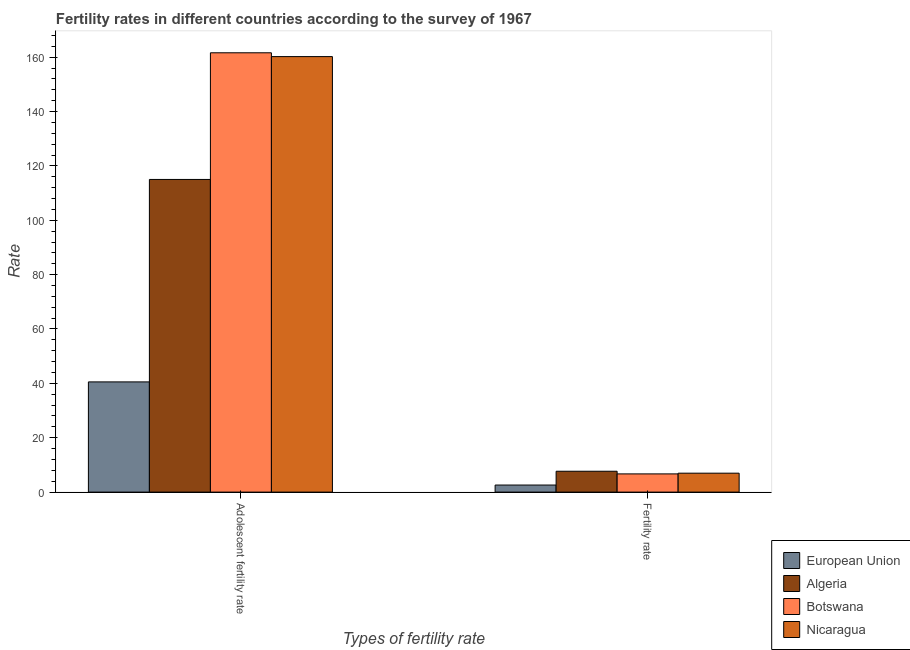How many groups of bars are there?
Your response must be concise. 2. How many bars are there on the 1st tick from the left?
Provide a short and direct response. 4. How many bars are there on the 1st tick from the right?
Keep it short and to the point. 4. What is the label of the 1st group of bars from the left?
Provide a succinct answer. Adolescent fertility rate. What is the adolescent fertility rate in Nicaragua?
Provide a succinct answer. 160.2. Across all countries, what is the maximum fertility rate?
Keep it short and to the point. 7.67. Across all countries, what is the minimum adolescent fertility rate?
Provide a short and direct response. 40.54. In which country was the adolescent fertility rate maximum?
Give a very brief answer. Botswana. What is the total adolescent fertility rate in the graph?
Your answer should be compact. 477.36. What is the difference between the adolescent fertility rate in Nicaragua and that in Botswana?
Provide a short and direct response. -1.4. What is the difference between the adolescent fertility rate in Algeria and the fertility rate in Nicaragua?
Give a very brief answer. 108.05. What is the average adolescent fertility rate per country?
Provide a short and direct response. 119.34. What is the difference between the fertility rate and adolescent fertility rate in Algeria?
Ensure brevity in your answer.  -107.34. What is the ratio of the adolescent fertility rate in Botswana to that in Algeria?
Keep it short and to the point. 1.41. What does the 1st bar from the left in Fertility rate represents?
Make the answer very short. European Union. What does the 4th bar from the right in Adolescent fertility rate represents?
Keep it short and to the point. European Union. How many countries are there in the graph?
Provide a short and direct response. 4. Are the values on the major ticks of Y-axis written in scientific E-notation?
Give a very brief answer. No. Does the graph contain any zero values?
Ensure brevity in your answer.  No. Does the graph contain grids?
Your answer should be compact. No. What is the title of the graph?
Ensure brevity in your answer.  Fertility rates in different countries according to the survey of 1967. What is the label or title of the X-axis?
Provide a succinct answer. Types of fertility rate. What is the label or title of the Y-axis?
Your answer should be compact. Rate. What is the Rate in European Union in Adolescent fertility rate?
Your response must be concise. 40.54. What is the Rate of Algeria in Adolescent fertility rate?
Make the answer very short. 115.01. What is the Rate in Botswana in Adolescent fertility rate?
Provide a short and direct response. 161.6. What is the Rate of Nicaragua in Adolescent fertility rate?
Your answer should be very brief. 160.2. What is the Rate of European Union in Fertility rate?
Provide a succinct answer. 2.6. What is the Rate of Algeria in Fertility rate?
Offer a terse response. 7.67. What is the Rate in Botswana in Fertility rate?
Offer a very short reply. 6.7. What is the Rate of Nicaragua in Fertility rate?
Your answer should be compact. 6.96. Across all Types of fertility rate, what is the maximum Rate of European Union?
Give a very brief answer. 40.54. Across all Types of fertility rate, what is the maximum Rate of Algeria?
Give a very brief answer. 115.01. Across all Types of fertility rate, what is the maximum Rate of Botswana?
Offer a terse response. 161.6. Across all Types of fertility rate, what is the maximum Rate of Nicaragua?
Your response must be concise. 160.2. Across all Types of fertility rate, what is the minimum Rate of European Union?
Keep it short and to the point. 2.6. Across all Types of fertility rate, what is the minimum Rate in Algeria?
Your answer should be very brief. 7.67. Across all Types of fertility rate, what is the minimum Rate of Botswana?
Keep it short and to the point. 6.7. Across all Types of fertility rate, what is the minimum Rate of Nicaragua?
Your answer should be very brief. 6.96. What is the total Rate in European Union in the graph?
Offer a terse response. 43.14. What is the total Rate in Algeria in the graph?
Make the answer very short. 122.68. What is the total Rate in Botswana in the graph?
Keep it short and to the point. 168.3. What is the total Rate of Nicaragua in the graph?
Make the answer very short. 167.16. What is the difference between the Rate of European Union in Adolescent fertility rate and that in Fertility rate?
Make the answer very short. 37.94. What is the difference between the Rate in Algeria in Adolescent fertility rate and that in Fertility rate?
Provide a short and direct response. 107.34. What is the difference between the Rate of Botswana in Adolescent fertility rate and that in Fertility rate?
Provide a short and direct response. 154.91. What is the difference between the Rate of Nicaragua in Adolescent fertility rate and that in Fertility rate?
Make the answer very short. 153.24. What is the difference between the Rate in European Union in Adolescent fertility rate and the Rate in Algeria in Fertility rate?
Offer a very short reply. 32.87. What is the difference between the Rate of European Union in Adolescent fertility rate and the Rate of Botswana in Fertility rate?
Give a very brief answer. 33.84. What is the difference between the Rate of European Union in Adolescent fertility rate and the Rate of Nicaragua in Fertility rate?
Your answer should be compact. 33.58. What is the difference between the Rate in Algeria in Adolescent fertility rate and the Rate in Botswana in Fertility rate?
Your answer should be very brief. 108.32. What is the difference between the Rate in Algeria in Adolescent fertility rate and the Rate in Nicaragua in Fertility rate?
Your answer should be very brief. 108.05. What is the difference between the Rate of Botswana in Adolescent fertility rate and the Rate of Nicaragua in Fertility rate?
Provide a short and direct response. 154.64. What is the average Rate of European Union per Types of fertility rate?
Provide a short and direct response. 21.57. What is the average Rate of Algeria per Types of fertility rate?
Your answer should be very brief. 61.34. What is the average Rate of Botswana per Types of fertility rate?
Provide a short and direct response. 84.15. What is the average Rate of Nicaragua per Types of fertility rate?
Provide a short and direct response. 83.58. What is the difference between the Rate of European Union and Rate of Algeria in Adolescent fertility rate?
Give a very brief answer. -74.47. What is the difference between the Rate of European Union and Rate of Botswana in Adolescent fertility rate?
Provide a short and direct response. -121.06. What is the difference between the Rate in European Union and Rate in Nicaragua in Adolescent fertility rate?
Ensure brevity in your answer.  -119.66. What is the difference between the Rate of Algeria and Rate of Botswana in Adolescent fertility rate?
Your answer should be very brief. -46.59. What is the difference between the Rate in Algeria and Rate in Nicaragua in Adolescent fertility rate?
Give a very brief answer. -45.19. What is the difference between the Rate in Botswana and Rate in Nicaragua in Adolescent fertility rate?
Your answer should be very brief. 1.4. What is the difference between the Rate in European Union and Rate in Algeria in Fertility rate?
Provide a succinct answer. -5.08. What is the difference between the Rate of European Union and Rate of Botswana in Fertility rate?
Keep it short and to the point. -4.1. What is the difference between the Rate in European Union and Rate in Nicaragua in Fertility rate?
Your response must be concise. -4.36. What is the difference between the Rate in Algeria and Rate in Botswana in Fertility rate?
Ensure brevity in your answer.  0.98. What is the difference between the Rate in Algeria and Rate in Nicaragua in Fertility rate?
Offer a terse response. 0.71. What is the difference between the Rate in Botswana and Rate in Nicaragua in Fertility rate?
Provide a succinct answer. -0.27. What is the ratio of the Rate of European Union in Adolescent fertility rate to that in Fertility rate?
Your answer should be compact. 15.61. What is the ratio of the Rate in Algeria in Adolescent fertility rate to that in Fertility rate?
Provide a short and direct response. 14.99. What is the ratio of the Rate of Botswana in Adolescent fertility rate to that in Fertility rate?
Give a very brief answer. 24.13. What is the ratio of the Rate of Nicaragua in Adolescent fertility rate to that in Fertility rate?
Offer a very short reply. 23.01. What is the difference between the highest and the second highest Rate of European Union?
Make the answer very short. 37.94. What is the difference between the highest and the second highest Rate in Algeria?
Offer a terse response. 107.34. What is the difference between the highest and the second highest Rate of Botswana?
Ensure brevity in your answer.  154.91. What is the difference between the highest and the second highest Rate of Nicaragua?
Provide a short and direct response. 153.24. What is the difference between the highest and the lowest Rate of European Union?
Offer a very short reply. 37.94. What is the difference between the highest and the lowest Rate in Algeria?
Make the answer very short. 107.34. What is the difference between the highest and the lowest Rate in Botswana?
Your answer should be compact. 154.91. What is the difference between the highest and the lowest Rate of Nicaragua?
Give a very brief answer. 153.24. 